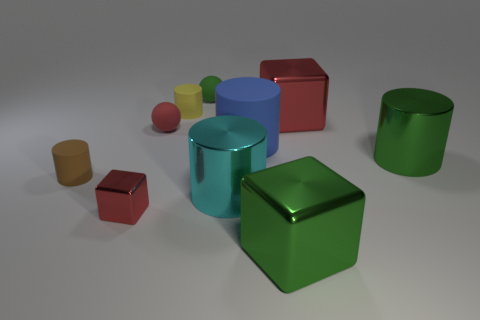Subtract all blue balls. How many red cubes are left? 2 Subtract all yellow cylinders. How many cylinders are left? 4 Subtract 1 cylinders. How many cylinders are left? 4 Subtract all large green metallic cylinders. How many cylinders are left? 4 Subtract all cyan cylinders. Subtract all blue blocks. How many cylinders are left? 4 Subtract all blocks. How many objects are left? 7 Subtract 1 green cylinders. How many objects are left? 9 Subtract all cylinders. Subtract all yellow shiny spheres. How many objects are left? 5 Add 6 small green things. How many small green things are left? 7 Add 2 big green cylinders. How many big green cylinders exist? 3 